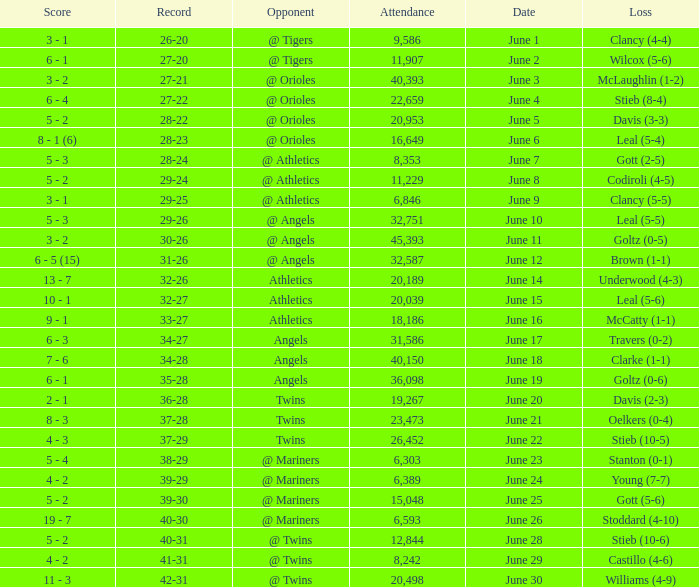What was the record for the date of June 14? 32-26. 